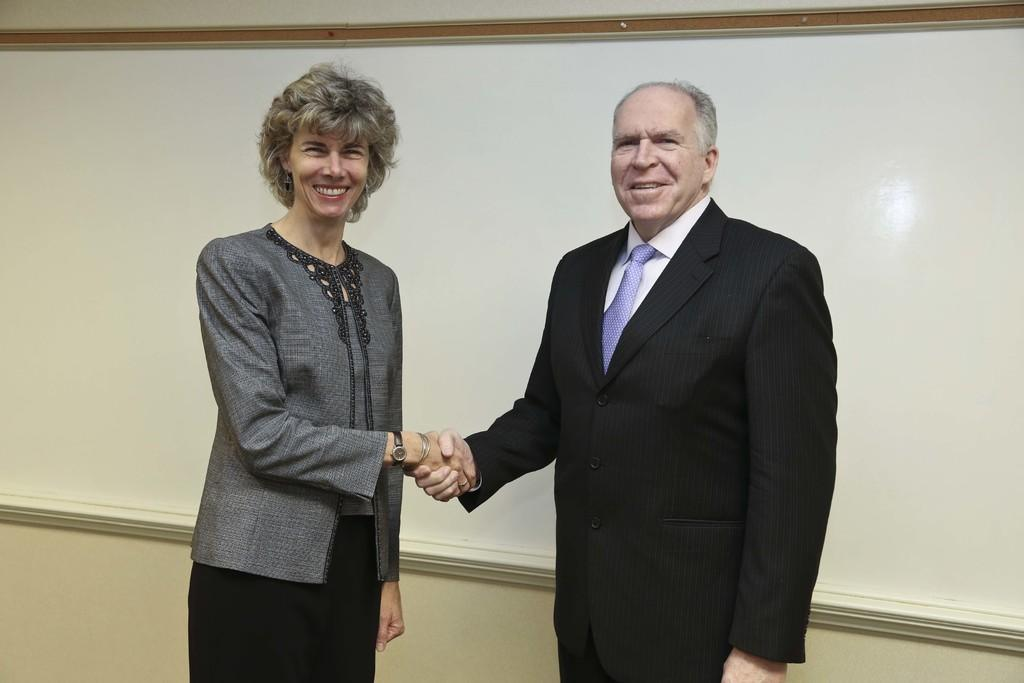How many people are present in the image? There are two people in the image. What colors are the people wearing? The people are wearing black, grey, white, and purple color dresses. What can be seen in the background of the image? There is a board attached to the wall in the background of the image. How many bottles are visible on the board in the image? There are no bottles present in the image; the board is attached to the wall in the background, but no objects are visible on it. 